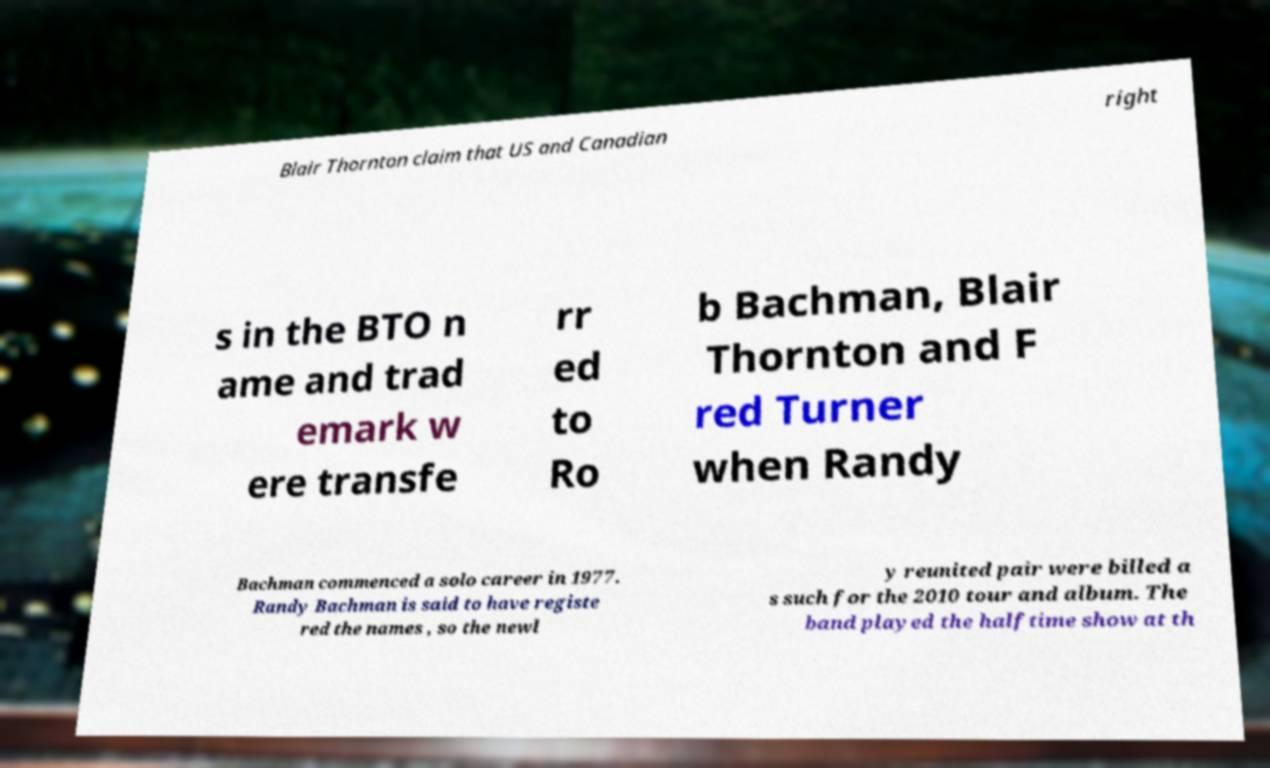What messages or text are displayed in this image? I need them in a readable, typed format. Blair Thornton claim that US and Canadian right s in the BTO n ame and trad emark w ere transfe rr ed to Ro b Bachman, Blair Thornton and F red Turner when Randy Bachman commenced a solo career in 1977. Randy Bachman is said to have registe red the names , so the newl y reunited pair were billed a s such for the 2010 tour and album. The band played the halftime show at th 